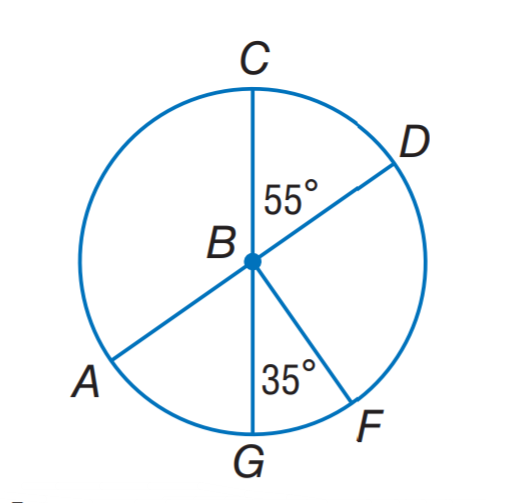Answer the mathemtical geometry problem and directly provide the correct option letter.
Question: A D and C G are diameters of \odot B. Find m \widehat A C F.
Choices: A: 265 B: 270 C: 295 D: 305 B 